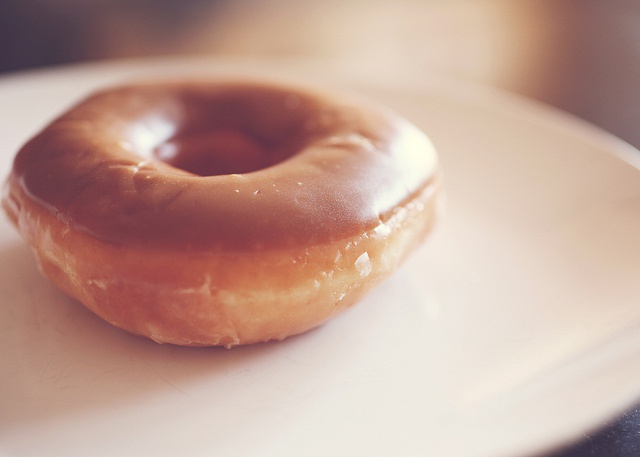Describe the objects in this image and their specific colors. I can see a donut in black, brown, tan, and lightgray tones in this image. 